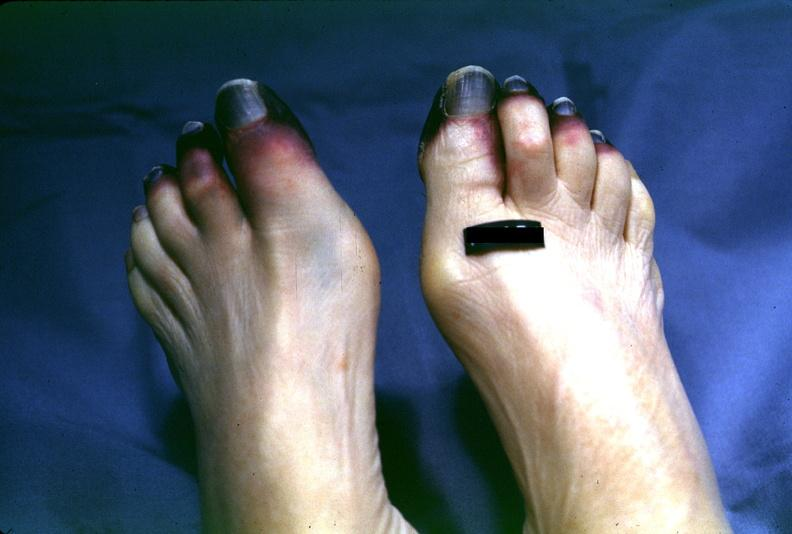what does this image show?
Answer the question using a single word or phrase. Toes 